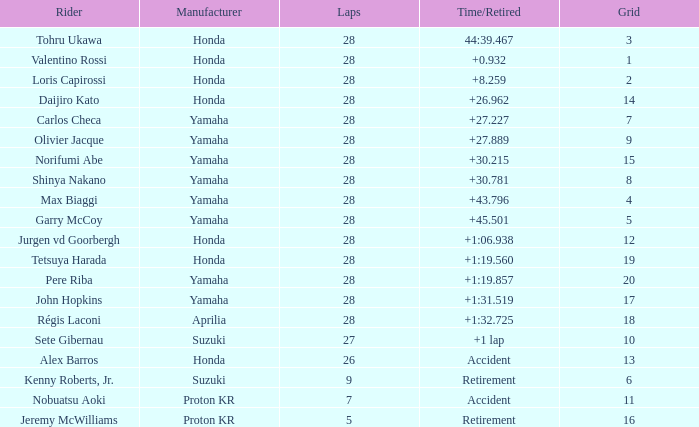Could you parse the entire table as a dict? {'header': ['Rider', 'Manufacturer', 'Laps', 'Time/Retired', 'Grid'], 'rows': [['Tohru Ukawa', 'Honda', '28', '44:39.467', '3'], ['Valentino Rossi', 'Honda', '28', '+0.932', '1'], ['Loris Capirossi', 'Honda', '28', '+8.259', '2'], ['Daijiro Kato', 'Honda', '28', '+26.962', '14'], ['Carlos Checa', 'Yamaha', '28', '+27.227', '7'], ['Olivier Jacque', 'Yamaha', '28', '+27.889', '9'], ['Norifumi Abe', 'Yamaha', '28', '+30.215', '15'], ['Shinya Nakano', 'Yamaha', '28', '+30.781', '8'], ['Max Biaggi', 'Yamaha', '28', '+43.796', '4'], ['Garry McCoy', 'Yamaha', '28', '+45.501', '5'], ['Jurgen vd Goorbergh', 'Honda', '28', '+1:06.938', '12'], ['Tetsuya Harada', 'Honda', '28', '+1:19.560', '19'], ['Pere Riba', 'Yamaha', '28', '+1:19.857', '20'], ['John Hopkins', 'Yamaha', '28', '+1:31.519', '17'], ['Régis Laconi', 'Aprilia', '28', '+1:32.725', '18'], ['Sete Gibernau', 'Suzuki', '27', '+1 lap', '10'], ['Alex Barros', 'Honda', '26', 'Accident', '13'], ['Kenny Roberts, Jr.', 'Suzuki', '9', 'Retirement', '6'], ['Nobuatsu Aoki', 'Proton KR', '7', 'Accident', '11'], ['Jeremy McWilliams', 'Proton KR', '5', 'Retirement', '16']]} Who manufactured grid 11? Proton KR. 